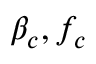Convert formula to latex. <formula><loc_0><loc_0><loc_500><loc_500>\beta _ { c } , f _ { c }</formula> 